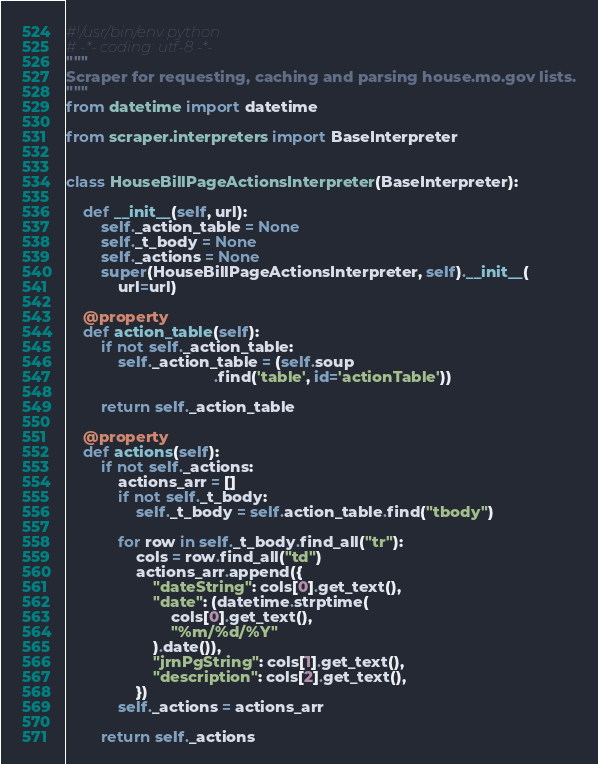Convert code to text. <code><loc_0><loc_0><loc_500><loc_500><_Python_>#!/usr/bin/env python
# -*- coding: utf-8 -*-
"""
Scraper for requesting, caching and parsing house.mo.gov lists.
"""
from datetime import datetime

from scraper.interpreters import BaseInterpreter


class HouseBillPageActionsInterpreter(BaseInterpreter):

    def __init__(self, url):
        self._action_table = None
        self._t_body = None
        self._actions = None
        super(HouseBillPageActionsInterpreter, self).__init__(
            url=url)

    @property
    def action_table(self):
        if not self._action_table:
            self._action_table = (self.soup
                                  .find('table', id='actionTable'))

        return self._action_table

    @property
    def actions(self):
        if not self._actions:
            actions_arr = []
            if not self._t_body:
                self._t_body = self.action_table.find("tbody")

            for row in self._t_body.find_all("tr"):
                cols = row.find_all("td")
                actions_arr.append({
                    "dateString": cols[0].get_text(),
                    "date": (datetime.strptime(
                        cols[0].get_text(),
                        "%m/%d/%Y"
                    ).date()),
                    "jrnPgString": cols[1].get_text(),
                    "description": cols[2].get_text(),
                })
            self._actions = actions_arr

        return self._actions
</code> 